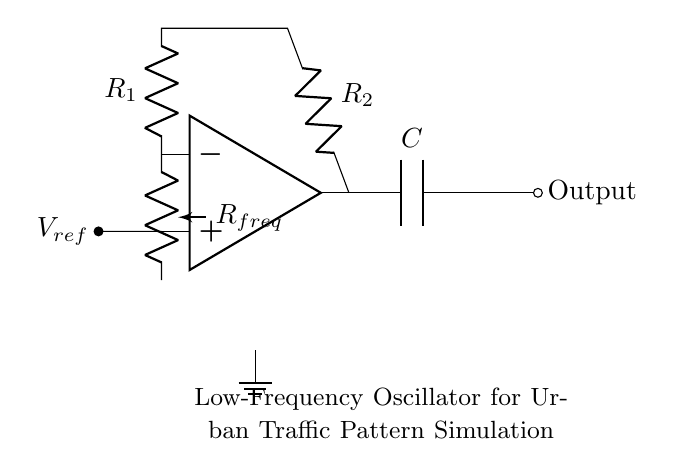What is the purpose of the op-amp in this circuit? The op-amp serves as a voltage amplifier, which is essential in an oscillator circuit to generate alternating signals. It processes the input voltage and helps in creating oscillations necessary for the simulation of traffic patterns.
Answer: Voltage amplifier What influences the frequency of the oscillator? The frequency of the oscillator is influenced by the resistor labeled "R_freq" and the capacitor. The values of these components dictate how quickly the circuit oscillates, with higher resistance or capacitance leading to lower frequencies.
Answer: Resistor and capacitor What component connects to the non-inverting input of the op-amp? The component connected to the non-inverting input of the op-amp is a reference voltage labeled "V_ref," which is crucial for stabilizing the required operating point of the op-amp in the oscillator.
Answer: V_ref How many resistors are present in the circuit? There are two resistors present in the circuit labeled "R_1" and "R_2." These resistors play critical roles in setting gain and defining the operating point of the circuit.
Answer: Two What happens at the output of the circuit? The output of the circuit produces a waveform signal which represents the simulated urban traffic patterns. This output is an alternating signal generated by the oscillatory action of the circuit.
Answer: Waveform signal Why is a potentiometer included in the circuit? The potentiometer allows for adjustable resistance. This adjustability lets users change the frequency of the oscillator, providing flexibility to match varying urban traffic simulation scenarios.
Answer: Adjustable resistance What circuit type is this? This is a low-frequency oscillator circuit, which is specifically designed for generating signals at low frequencies, ideal for simulating real-world phenomena like urban traffic patterns.
Answer: Low-frequency oscillator 